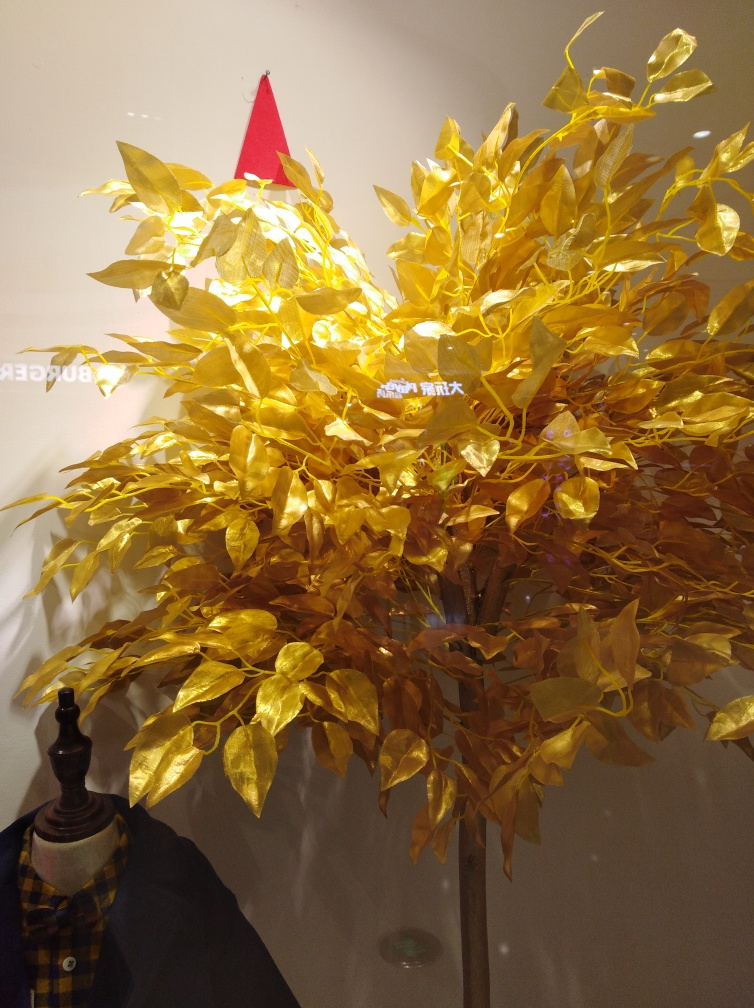What could be the significance of the golden leaves? Golden leaves often symbolize prosperity, wealth, and success. In various cultures, gold is seen as a sign of high value and status. In this context, particularly if this is a holiday display, the golden leaves could invoke feelings of warmth, celebration, and perhaps the spirit of giving that is commonly associated with festive seasons. Do you think the tree could symbolize anything specific? It could symbolize various themes depending on the context. If this is part of a holiday display, the tree might symbolize growth, life, and renewal. Given its golden color, it might also represent a celebration of abundance and luminescence during a festive time. The festive hat at the top reinforces the notion of celebration and could hint at specific holiday festivities. 